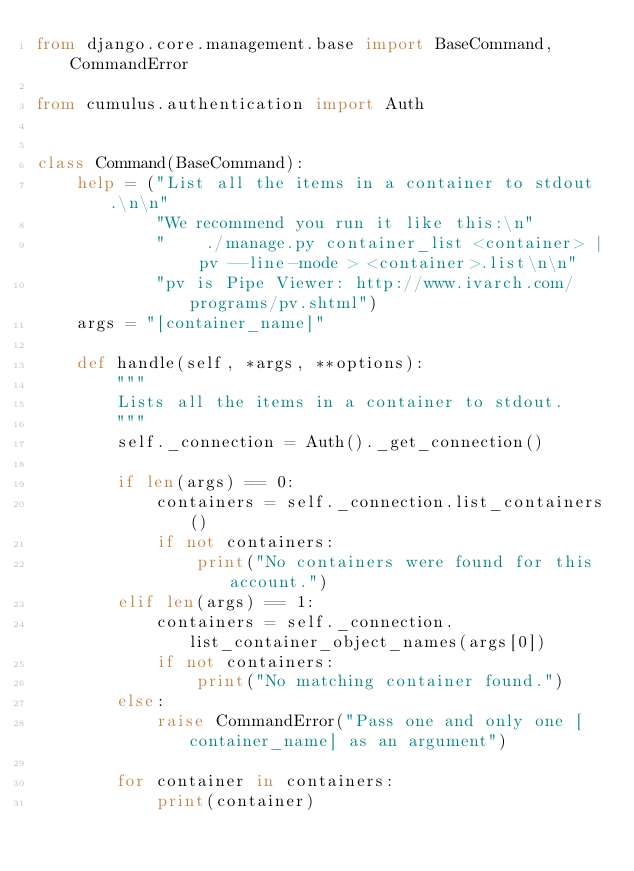Convert code to text. <code><loc_0><loc_0><loc_500><loc_500><_Python_>from django.core.management.base import BaseCommand, CommandError

from cumulus.authentication import Auth


class Command(BaseCommand):
    help = ("List all the items in a container to stdout.\n\n"
            "We recommend you run it like this:\n"
            "    ./manage.py container_list <container> | pv --line-mode > <container>.list\n\n"
            "pv is Pipe Viewer: http://www.ivarch.com/programs/pv.shtml")
    args = "[container_name]"

    def handle(self, *args, **options):
        """
        Lists all the items in a container to stdout.
        """
        self._connection = Auth()._get_connection()

        if len(args) == 0:
            containers = self._connection.list_containers()
            if not containers:
                print("No containers were found for this account.")
        elif len(args) == 1:
            containers = self._connection.list_container_object_names(args[0])
            if not containers:
                print("No matching container found.")
        else:
            raise CommandError("Pass one and only one [container_name] as an argument")

        for container in containers:
            print(container)
</code> 